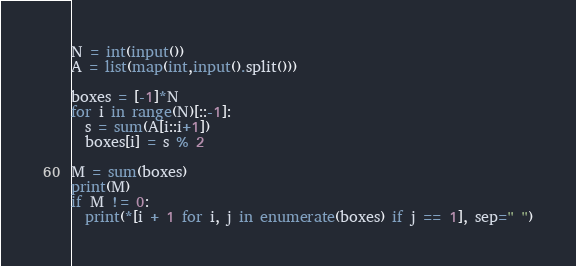Convert code to text. <code><loc_0><loc_0><loc_500><loc_500><_Python_>N = int(input())
A = list(map(int,input().split()))

boxes = [-1]*N
for i in range(N)[::-1]:
  s = sum(A[i::i+1])
  boxes[i] = s % 2

M = sum(boxes)
print(M)
if M != 0:
  print(*[i + 1 for i, j in enumerate(boxes) if j == 1], sep=" ")</code> 